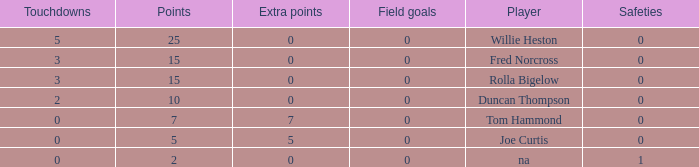How many Touchdowns have a Player of rolla bigelow, and an Extra points smaller than 0? None. 